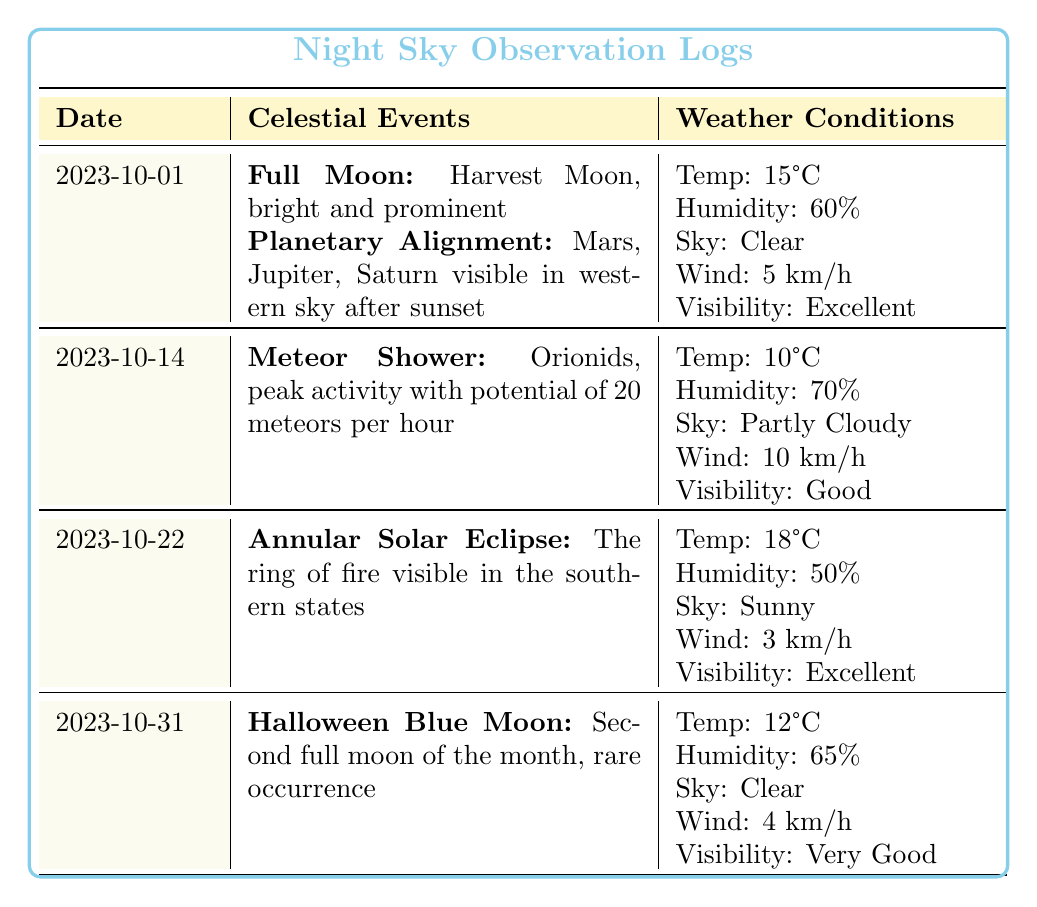What celestial event occurred on October 22, 2023? According to the table, the celestial event noted for October 22, 2023, is the "Annular Solar Eclipse."
Answer: Annular Solar Eclipse What was the temperature on October 14, 2023? The table states that the temperature recorded on October 14, 2023, was 10°C.
Answer: 10°C Did the skies clear on Halloween, October 31, 2023? Yes, the table indicates that the sky condition on October 31, 2023, was "Clear."
Answer: Yes Which date had the highest humidity, and what was it? To determine this, we look at the humidity values: 60% (October 1), 70% (October 14), 50% (October 22), and 65% (October 31). The highest humidity is 70% recorded on October 14.
Answer: October 14, 70% What was the average temperature across all observation dates? The temperatures are 15°C, 10°C, 18°C, and 12°C. Adding these gives us 15 + 10 + 18 + 12 = 55°C. Dividing by the number of observations (4), we find the average temperature to be 55/4 = 13.75°C.
Answer: 13.75°C Did the October 1 observation include a Meteor Shower? No, the entries for October 1 list a Full Moon and a Planetary Alignment, but do not mention a Meteor Shower.
Answer: No Which date had a visibility rating of "Very Good" and what was the humidity on that date? The date with "Very Good" visibility is October 31, and according to the table, the humidity on that date was 65%.
Answer: October 31, 65% How many celestial events were recorded on October 1? There are two celestial events listed for October 1, which are the Full Moon and the Planetary Alignment.
Answer: 2 What was the weather condition on the date with the Meteor Shower event? The Meteor Shower event occurred on October 14, where the weather conditions were: Temperature 10°C, Humidity 70%, Sky condition Partly Cloudy, WindSpeed 10 km/h, Visibility Good.
Answer: Partly Cloudy, 10°C, 70%, Good Visibility 